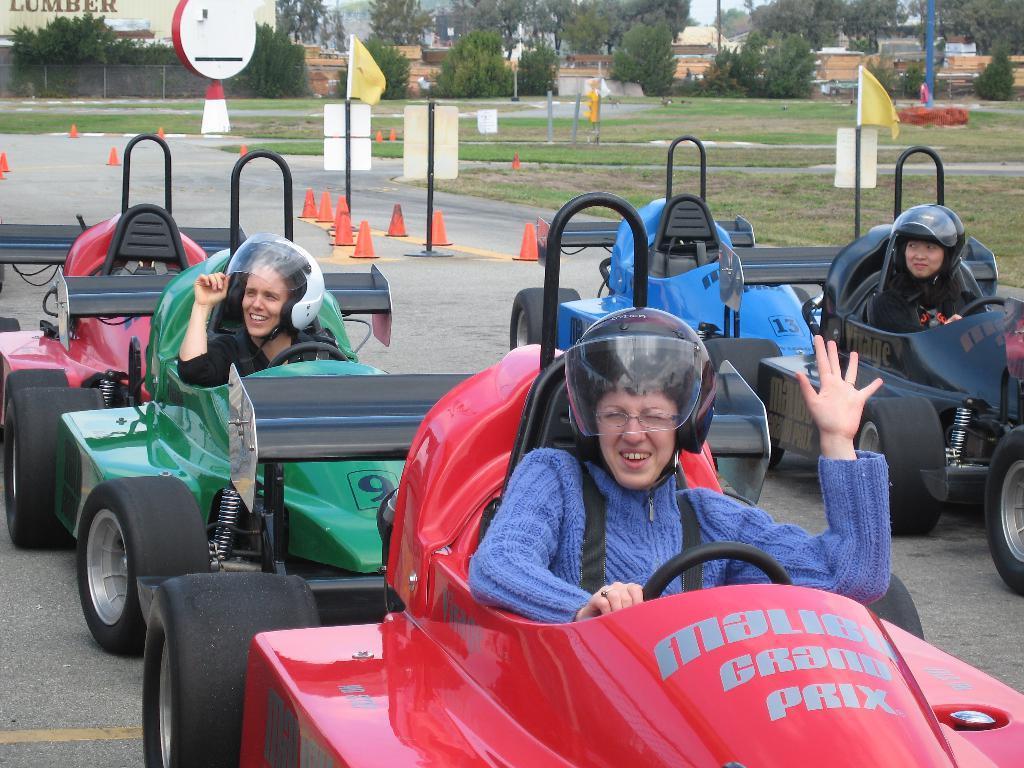Could you give a brief overview of what you see in this image? In this image I can see few persons wearing helmets are riding cars on the road. In the background I can see few traffic poles, few boards to the poles, few trees, few buildings, few flags, some grass and the sky. 